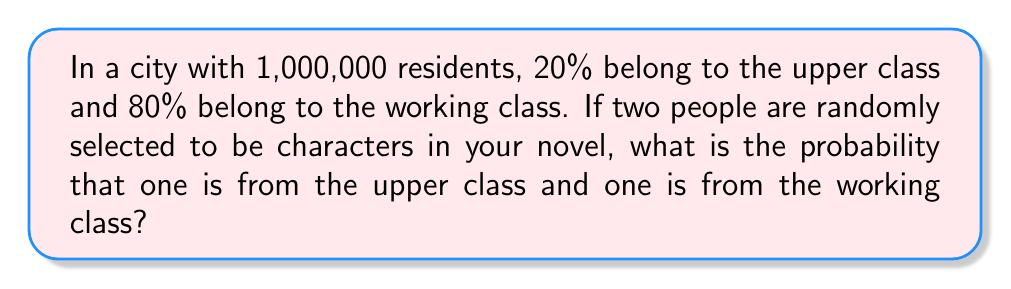Show me your answer to this math problem. Let's approach this step-by-step:

1) First, we need to calculate the number of people in each class:
   Upper class: $1,000,000 \times 0.20 = 200,000$
   Working class: $1,000,000 \times 0.80 = 800,000$

2) Now, we need to consider the probability of selecting one person from each class. This can happen in two ways:
   a) First person is upper class, second is working class
   b) First person is working class, second is upper class

3) Let's calculate the probability of scenario a:
   P(first upper, second working) = $\frac{200,000}{1,000,000} \times \frac{800,000}{999,999}$

4) The probability of scenario b is:
   P(first working, second upper) = $\frac{800,000}{1,000,000} \times \frac{200,000}{999,999}$

5) The total probability is the sum of these two scenarios:

   $$P(\text{one upper, one working}) = \frac{200,000}{1,000,000} \times \frac{800,000}{999,999} + \frac{800,000}{1,000,000} \times \frac{200,000}{999,999}$$

6) Simplifying:
   $$P = \frac{200 \times 800}{1000 \times 999,999} + \frac{800 \times 200}{1000 \times 999,999} = \frac{320,000}{999,999}$$

7) This can be further simplified to:
   $$P = \frac{320,000}{999,999} = \frac{32}{100}$$
Answer: $\frac{32}{100}$ or 0.32 or 32% 